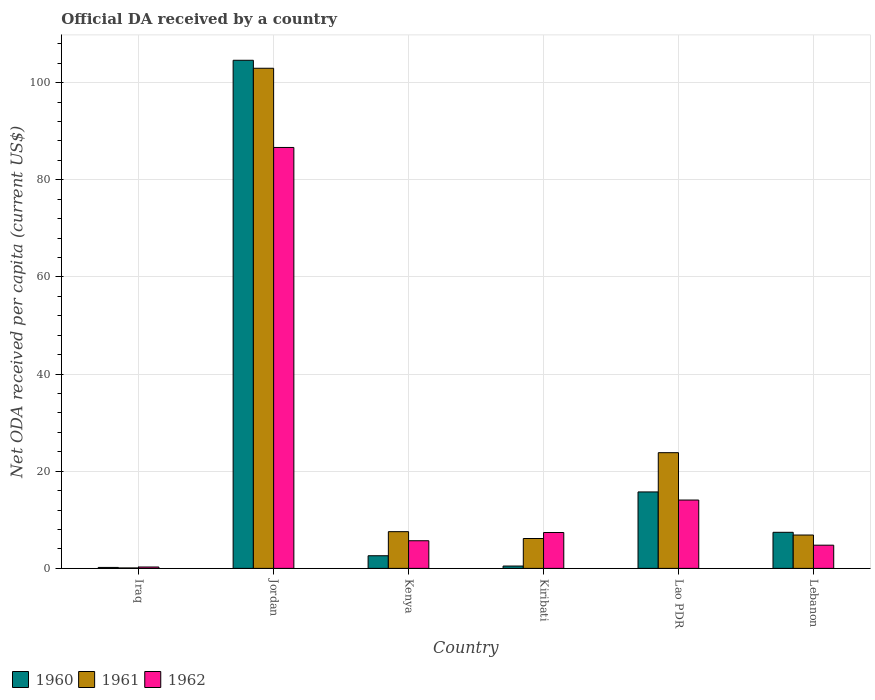How many different coloured bars are there?
Offer a very short reply. 3. Are the number of bars on each tick of the X-axis equal?
Keep it short and to the point. Yes. How many bars are there on the 4th tick from the left?
Offer a terse response. 3. How many bars are there on the 2nd tick from the right?
Offer a terse response. 3. What is the label of the 5th group of bars from the left?
Your answer should be compact. Lao PDR. In how many cases, is the number of bars for a given country not equal to the number of legend labels?
Provide a succinct answer. 0. What is the ODA received in in 1960 in Lebanon?
Your answer should be very brief. 7.43. Across all countries, what is the maximum ODA received in in 1961?
Keep it short and to the point. 102.97. Across all countries, what is the minimum ODA received in in 1960?
Your response must be concise. 0.2. In which country was the ODA received in in 1961 maximum?
Offer a terse response. Jordan. In which country was the ODA received in in 1961 minimum?
Offer a very short reply. Iraq. What is the total ODA received in in 1960 in the graph?
Ensure brevity in your answer.  131.07. What is the difference between the ODA received in in 1960 in Iraq and that in Kiribati?
Your response must be concise. -0.29. What is the difference between the ODA received in in 1961 in Iraq and the ODA received in in 1960 in Jordan?
Make the answer very short. -104.52. What is the average ODA received in in 1960 per country?
Offer a very short reply. 21.84. What is the difference between the ODA received in of/in 1960 and ODA received in of/in 1962 in Lao PDR?
Give a very brief answer. 1.67. In how many countries, is the ODA received in in 1961 greater than 12 US$?
Offer a very short reply. 2. What is the ratio of the ODA received in in 1961 in Kiribati to that in Lebanon?
Offer a terse response. 0.9. Is the ODA received in in 1961 in Iraq less than that in Kenya?
Ensure brevity in your answer.  Yes. Is the difference between the ODA received in in 1960 in Kiribati and Lebanon greater than the difference between the ODA received in in 1962 in Kiribati and Lebanon?
Offer a terse response. No. What is the difference between the highest and the second highest ODA received in in 1961?
Make the answer very short. -95.4. What is the difference between the highest and the lowest ODA received in in 1960?
Ensure brevity in your answer.  104.41. Is the sum of the ODA received in in 1961 in Kenya and Lao PDR greater than the maximum ODA received in in 1960 across all countries?
Ensure brevity in your answer.  No. What does the 1st bar from the left in Iraq represents?
Your response must be concise. 1960. What does the 1st bar from the right in Jordan represents?
Provide a short and direct response. 1962. How many bars are there?
Your answer should be very brief. 18. Are all the bars in the graph horizontal?
Your response must be concise. No. How many countries are there in the graph?
Give a very brief answer. 6. Are the values on the major ticks of Y-axis written in scientific E-notation?
Your response must be concise. No. Where does the legend appear in the graph?
Provide a short and direct response. Bottom left. How many legend labels are there?
Offer a very short reply. 3. How are the legend labels stacked?
Your answer should be compact. Horizontal. What is the title of the graph?
Your answer should be compact. Official DA received by a country. What is the label or title of the X-axis?
Your answer should be compact. Country. What is the label or title of the Y-axis?
Keep it short and to the point. Net ODA received per capita (current US$). What is the Net ODA received per capita (current US$) in 1960 in Iraq?
Keep it short and to the point. 0.2. What is the Net ODA received per capita (current US$) of 1961 in Iraq?
Keep it short and to the point. 0.09. What is the Net ODA received per capita (current US$) in 1962 in Iraq?
Your response must be concise. 0.28. What is the Net ODA received per capita (current US$) of 1960 in Jordan?
Offer a terse response. 104.61. What is the Net ODA received per capita (current US$) in 1961 in Jordan?
Give a very brief answer. 102.97. What is the Net ODA received per capita (current US$) in 1962 in Jordan?
Your answer should be very brief. 86.66. What is the Net ODA received per capita (current US$) of 1960 in Kenya?
Your response must be concise. 2.6. What is the Net ODA received per capita (current US$) of 1961 in Kenya?
Make the answer very short. 7.56. What is the Net ODA received per capita (current US$) of 1962 in Kenya?
Offer a very short reply. 5.69. What is the Net ODA received per capita (current US$) of 1960 in Kiribati?
Make the answer very short. 0.49. What is the Net ODA received per capita (current US$) in 1961 in Kiribati?
Your answer should be very brief. 6.15. What is the Net ODA received per capita (current US$) in 1962 in Kiribati?
Offer a terse response. 7.39. What is the Net ODA received per capita (current US$) in 1960 in Lao PDR?
Offer a terse response. 15.74. What is the Net ODA received per capita (current US$) in 1961 in Lao PDR?
Keep it short and to the point. 23.82. What is the Net ODA received per capita (current US$) in 1962 in Lao PDR?
Offer a terse response. 14.07. What is the Net ODA received per capita (current US$) of 1960 in Lebanon?
Provide a succinct answer. 7.43. What is the Net ODA received per capita (current US$) in 1961 in Lebanon?
Your answer should be very brief. 6.87. What is the Net ODA received per capita (current US$) in 1962 in Lebanon?
Make the answer very short. 4.78. Across all countries, what is the maximum Net ODA received per capita (current US$) of 1960?
Provide a short and direct response. 104.61. Across all countries, what is the maximum Net ODA received per capita (current US$) in 1961?
Provide a succinct answer. 102.97. Across all countries, what is the maximum Net ODA received per capita (current US$) in 1962?
Make the answer very short. 86.66. Across all countries, what is the minimum Net ODA received per capita (current US$) in 1960?
Make the answer very short. 0.2. Across all countries, what is the minimum Net ODA received per capita (current US$) in 1961?
Ensure brevity in your answer.  0.09. Across all countries, what is the minimum Net ODA received per capita (current US$) in 1962?
Make the answer very short. 0.28. What is the total Net ODA received per capita (current US$) in 1960 in the graph?
Offer a very short reply. 131.07. What is the total Net ODA received per capita (current US$) in 1961 in the graph?
Keep it short and to the point. 147.47. What is the total Net ODA received per capita (current US$) in 1962 in the graph?
Provide a short and direct response. 118.88. What is the difference between the Net ODA received per capita (current US$) of 1960 in Iraq and that in Jordan?
Your answer should be very brief. -104.41. What is the difference between the Net ODA received per capita (current US$) in 1961 in Iraq and that in Jordan?
Offer a very short reply. -102.88. What is the difference between the Net ODA received per capita (current US$) of 1962 in Iraq and that in Jordan?
Your answer should be compact. -86.38. What is the difference between the Net ODA received per capita (current US$) of 1960 in Iraq and that in Kenya?
Your answer should be compact. -2.41. What is the difference between the Net ODA received per capita (current US$) in 1961 in Iraq and that in Kenya?
Ensure brevity in your answer.  -7.47. What is the difference between the Net ODA received per capita (current US$) of 1962 in Iraq and that in Kenya?
Provide a short and direct response. -5.41. What is the difference between the Net ODA received per capita (current US$) of 1960 in Iraq and that in Kiribati?
Give a very brief answer. -0.29. What is the difference between the Net ODA received per capita (current US$) in 1961 in Iraq and that in Kiribati?
Your answer should be compact. -6.06. What is the difference between the Net ODA received per capita (current US$) of 1962 in Iraq and that in Kiribati?
Ensure brevity in your answer.  -7.1. What is the difference between the Net ODA received per capita (current US$) in 1960 in Iraq and that in Lao PDR?
Offer a very short reply. -15.54. What is the difference between the Net ODA received per capita (current US$) of 1961 in Iraq and that in Lao PDR?
Keep it short and to the point. -23.73. What is the difference between the Net ODA received per capita (current US$) in 1962 in Iraq and that in Lao PDR?
Provide a short and direct response. -13.79. What is the difference between the Net ODA received per capita (current US$) of 1960 in Iraq and that in Lebanon?
Provide a short and direct response. -7.23. What is the difference between the Net ODA received per capita (current US$) of 1961 in Iraq and that in Lebanon?
Make the answer very short. -6.78. What is the difference between the Net ODA received per capita (current US$) in 1962 in Iraq and that in Lebanon?
Your answer should be compact. -4.49. What is the difference between the Net ODA received per capita (current US$) of 1960 in Jordan and that in Kenya?
Keep it short and to the point. 102. What is the difference between the Net ODA received per capita (current US$) in 1961 in Jordan and that in Kenya?
Your response must be concise. 95.4. What is the difference between the Net ODA received per capita (current US$) in 1962 in Jordan and that in Kenya?
Give a very brief answer. 80.97. What is the difference between the Net ODA received per capita (current US$) in 1960 in Jordan and that in Kiribati?
Make the answer very short. 104.12. What is the difference between the Net ODA received per capita (current US$) of 1961 in Jordan and that in Kiribati?
Give a very brief answer. 96.81. What is the difference between the Net ODA received per capita (current US$) of 1962 in Jordan and that in Kiribati?
Your answer should be compact. 79.27. What is the difference between the Net ODA received per capita (current US$) of 1960 in Jordan and that in Lao PDR?
Your answer should be compact. 88.87. What is the difference between the Net ODA received per capita (current US$) in 1961 in Jordan and that in Lao PDR?
Your answer should be very brief. 79.14. What is the difference between the Net ODA received per capita (current US$) of 1962 in Jordan and that in Lao PDR?
Offer a very short reply. 72.59. What is the difference between the Net ODA received per capita (current US$) in 1960 in Jordan and that in Lebanon?
Your response must be concise. 97.18. What is the difference between the Net ODA received per capita (current US$) of 1961 in Jordan and that in Lebanon?
Provide a short and direct response. 96.1. What is the difference between the Net ODA received per capita (current US$) of 1962 in Jordan and that in Lebanon?
Make the answer very short. 81.88. What is the difference between the Net ODA received per capita (current US$) of 1960 in Kenya and that in Kiribati?
Provide a short and direct response. 2.12. What is the difference between the Net ODA received per capita (current US$) of 1961 in Kenya and that in Kiribati?
Give a very brief answer. 1.41. What is the difference between the Net ODA received per capita (current US$) of 1962 in Kenya and that in Kiribati?
Provide a succinct answer. -1.7. What is the difference between the Net ODA received per capita (current US$) in 1960 in Kenya and that in Lao PDR?
Keep it short and to the point. -13.14. What is the difference between the Net ODA received per capita (current US$) of 1961 in Kenya and that in Lao PDR?
Provide a succinct answer. -16.26. What is the difference between the Net ODA received per capita (current US$) in 1962 in Kenya and that in Lao PDR?
Offer a terse response. -8.38. What is the difference between the Net ODA received per capita (current US$) in 1960 in Kenya and that in Lebanon?
Your answer should be compact. -4.83. What is the difference between the Net ODA received per capita (current US$) of 1961 in Kenya and that in Lebanon?
Offer a terse response. 0.69. What is the difference between the Net ODA received per capita (current US$) of 1962 in Kenya and that in Lebanon?
Give a very brief answer. 0.91. What is the difference between the Net ODA received per capita (current US$) in 1960 in Kiribati and that in Lao PDR?
Offer a very short reply. -15.26. What is the difference between the Net ODA received per capita (current US$) in 1961 in Kiribati and that in Lao PDR?
Give a very brief answer. -17.67. What is the difference between the Net ODA received per capita (current US$) in 1962 in Kiribati and that in Lao PDR?
Keep it short and to the point. -6.68. What is the difference between the Net ODA received per capita (current US$) of 1960 in Kiribati and that in Lebanon?
Provide a short and direct response. -6.94. What is the difference between the Net ODA received per capita (current US$) of 1961 in Kiribati and that in Lebanon?
Provide a succinct answer. -0.72. What is the difference between the Net ODA received per capita (current US$) of 1962 in Kiribati and that in Lebanon?
Make the answer very short. 2.61. What is the difference between the Net ODA received per capita (current US$) of 1960 in Lao PDR and that in Lebanon?
Keep it short and to the point. 8.31. What is the difference between the Net ODA received per capita (current US$) of 1961 in Lao PDR and that in Lebanon?
Give a very brief answer. 16.95. What is the difference between the Net ODA received per capita (current US$) in 1962 in Lao PDR and that in Lebanon?
Give a very brief answer. 9.29. What is the difference between the Net ODA received per capita (current US$) of 1960 in Iraq and the Net ODA received per capita (current US$) of 1961 in Jordan?
Ensure brevity in your answer.  -102.77. What is the difference between the Net ODA received per capita (current US$) in 1960 in Iraq and the Net ODA received per capita (current US$) in 1962 in Jordan?
Provide a short and direct response. -86.46. What is the difference between the Net ODA received per capita (current US$) in 1961 in Iraq and the Net ODA received per capita (current US$) in 1962 in Jordan?
Offer a terse response. -86.57. What is the difference between the Net ODA received per capita (current US$) in 1960 in Iraq and the Net ODA received per capita (current US$) in 1961 in Kenya?
Provide a short and direct response. -7.36. What is the difference between the Net ODA received per capita (current US$) of 1960 in Iraq and the Net ODA received per capita (current US$) of 1962 in Kenya?
Provide a short and direct response. -5.49. What is the difference between the Net ODA received per capita (current US$) in 1961 in Iraq and the Net ODA received per capita (current US$) in 1962 in Kenya?
Provide a short and direct response. -5.6. What is the difference between the Net ODA received per capita (current US$) of 1960 in Iraq and the Net ODA received per capita (current US$) of 1961 in Kiribati?
Keep it short and to the point. -5.95. What is the difference between the Net ODA received per capita (current US$) in 1960 in Iraq and the Net ODA received per capita (current US$) in 1962 in Kiribati?
Offer a terse response. -7.19. What is the difference between the Net ODA received per capita (current US$) of 1961 in Iraq and the Net ODA received per capita (current US$) of 1962 in Kiribati?
Give a very brief answer. -7.3. What is the difference between the Net ODA received per capita (current US$) of 1960 in Iraq and the Net ODA received per capita (current US$) of 1961 in Lao PDR?
Give a very brief answer. -23.62. What is the difference between the Net ODA received per capita (current US$) of 1960 in Iraq and the Net ODA received per capita (current US$) of 1962 in Lao PDR?
Your response must be concise. -13.87. What is the difference between the Net ODA received per capita (current US$) in 1961 in Iraq and the Net ODA received per capita (current US$) in 1962 in Lao PDR?
Provide a short and direct response. -13.98. What is the difference between the Net ODA received per capita (current US$) in 1960 in Iraq and the Net ODA received per capita (current US$) in 1961 in Lebanon?
Offer a very short reply. -6.67. What is the difference between the Net ODA received per capita (current US$) in 1960 in Iraq and the Net ODA received per capita (current US$) in 1962 in Lebanon?
Your answer should be very brief. -4.58. What is the difference between the Net ODA received per capita (current US$) of 1961 in Iraq and the Net ODA received per capita (current US$) of 1962 in Lebanon?
Offer a very short reply. -4.69. What is the difference between the Net ODA received per capita (current US$) of 1960 in Jordan and the Net ODA received per capita (current US$) of 1961 in Kenya?
Make the answer very short. 97.05. What is the difference between the Net ODA received per capita (current US$) of 1960 in Jordan and the Net ODA received per capita (current US$) of 1962 in Kenya?
Ensure brevity in your answer.  98.92. What is the difference between the Net ODA received per capita (current US$) in 1961 in Jordan and the Net ODA received per capita (current US$) in 1962 in Kenya?
Make the answer very short. 97.27. What is the difference between the Net ODA received per capita (current US$) of 1960 in Jordan and the Net ODA received per capita (current US$) of 1961 in Kiribati?
Your answer should be compact. 98.46. What is the difference between the Net ODA received per capita (current US$) in 1960 in Jordan and the Net ODA received per capita (current US$) in 1962 in Kiribati?
Your answer should be very brief. 97.22. What is the difference between the Net ODA received per capita (current US$) in 1961 in Jordan and the Net ODA received per capita (current US$) in 1962 in Kiribati?
Offer a terse response. 95.58. What is the difference between the Net ODA received per capita (current US$) of 1960 in Jordan and the Net ODA received per capita (current US$) of 1961 in Lao PDR?
Give a very brief answer. 80.79. What is the difference between the Net ODA received per capita (current US$) of 1960 in Jordan and the Net ODA received per capita (current US$) of 1962 in Lao PDR?
Your answer should be compact. 90.54. What is the difference between the Net ODA received per capita (current US$) in 1961 in Jordan and the Net ODA received per capita (current US$) in 1962 in Lao PDR?
Make the answer very short. 88.89. What is the difference between the Net ODA received per capita (current US$) of 1960 in Jordan and the Net ODA received per capita (current US$) of 1961 in Lebanon?
Provide a short and direct response. 97.74. What is the difference between the Net ODA received per capita (current US$) in 1960 in Jordan and the Net ODA received per capita (current US$) in 1962 in Lebanon?
Your answer should be very brief. 99.83. What is the difference between the Net ODA received per capita (current US$) of 1961 in Jordan and the Net ODA received per capita (current US$) of 1962 in Lebanon?
Offer a terse response. 98.19. What is the difference between the Net ODA received per capita (current US$) of 1960 in Kenya and the Net ODA received per capita (current US$) of 1961 in Kiribati?
Ensure brevity in your answer.  -3.55. What is the difference between the Net ODA received per capita (current US$) of 1960 in Kenya and the Net ODA received per capita (current US$) of 1962 in Kiribati?
Keep it short and to the point. -4.78. What is the difference between the Net ODA received per capita (current US$) of 1961 in Kenya and the Net ODA received per capita (current US$) of 1962 in Kiribati?
Offer a terse response. 0.17. What is the difference between the Net ODA received per capita (current US$) in 1960 in Kenya and the Net ODA received per capita (current US$) in 1961 in Lao PDR?
Provide a short and direct response. -21.22. What is the difference between the Net ODA received per capita (current US$) of 1960 in Kenya and the Net ODA received per capita (current US$) of 1962 in Lao PDR?
Provide a short and direct response. -11.47. What is the difference between the Net ODA received per capita (current US$) in 1961 in Kenya and the Net ODA received per capita (current US$) in 1962 in Lao PDR?
Make the answer very short. -6.51. What is the difference between the Net ODA received per capita (current US$) of 1960 in Kenya and the Net ODA received per capita (current US$) of 1961 in Lebanon?
Your answer should be very brief. -4.27. What is the difference between the Net ODA received per capita (current US$) in 1960 in Kenya and the Net ODA received per capita (current US$) in 1962 in Lebanon?
Your answer should be very brief. -2.17. What is the difference between the Net ODA received per capita (current US$) in 1961 in Kenya and the Net ODA received per capita (current US$) in 1962 in Lebanon?
Offer a very short reply. 2.78. What is the difference between the Net ODA received per capita (current US$) of 1960 in Kiribati and the Net ODA received per capita (current US$) of 1961 in Lao PDR?
Ensure brevity in your answer.  -23.34. What is the difference between the Net ODA received per capita (current US$) in 1960 in Kiribati and the Net ODA received per capita (current US$) in 1962 in Lao PDR?
Make the answer very short. -13.59. What is the difference between the Net ODA received per capita (current US$) in 1961 in Kiribati and the Net ODA received per capita (current US$) in 1962 in Lao PDR?
Give a very brief answer. -7.92. What is the difference between the Net ODA received per capita (current US$) of 1960 in Kiribati and the Net ODA received per capita (current US$) of 1961 in Lebanon?
Give a very brief answer. -6.39. What is the difference between the Net ODA received per capita (current US$) of 1960 in Kiribati and the Net ODA received per capita (current US$) of 1962 in Lebanon?
Provide a succinct answer. -4.29. What is the difference between the Net ODA received per capita (current US$) in 1961 in Kiribati and the Net ODA received per capita (current US$) in 1962 in Lebanon?
Your answer should be very brief. 1.37. What is the difference between the Net ODA received per capita (current US$) of 1960 in Lao PDR and the Net ODA received per capita (current US$) of 1961 in Lebanon?
Offer a very short reply. 8.87. What is the difference between the Net ODA received per capita (current US$) in 1960 in Lao PDR and the Net ODA received per capita (current US$) in 1962 in Lebanon?
Your response must be concise. 10.96. What is the difference between the Net ODA received per capita (current US$) of 1961 in Lao PDR and the Net ODA received per capita (current US$) of 1962 in Lebanon?
Your answer should be very brief. 19.05. What is the average Net ODA received per capita (current US$) of 1960 per country?
Offer a terse response. 21.84. What is the average Net ODA received per capita (current US$) in 1961 per country?
Make the answer very short. 24.58. What is the average Net ODA received per capita (current US$) of 1962 per country?
Your answer should be compact. 19.81. What is the difference between the Net ODA received per capita (current US$) of 1960 and Net ODA received per capita (current US$) of 1961 in Iraq?
Provide a short and direct response. 0.11. What is the difference between the Net ODA received per capita (current US$) of 1960 and Net ODA received per capita (current US$) of 1962 in Iraq?
Make the answer very short. -0.09. What is the difference between the Net ODA received per capita (current US$) in 1961 and Net ODA received per capita (current US$) in 1962 in Iraq?
Your response must be concise. -0.19. What is the difference between the Net ODA received per capita (current US$) of 1960 and Net ODA received per capita (current US$) of 1961 in Jordan?
Provide a succinct answer. 1.64. What is the difference between the Net ODA received per capita (current US$) in 1960 and Net ODA received per capita (current US$) in 1962 in Jordan?
Make the answer very short. 17.95. What is the difference between the Net ODA received per capita (current US$) in 1961 and Net ODA received per capita (current US$) in 1962 in Jordan?
Keep it short and to the point. 16.3. What is the difference between the Net ODA received per capita (current US$) of 1960 and Net ODA received per capita (current US$) of 1961 in Kenya?
Offer a terse response. -4.96. What is the difference between the Net ODA received per capita (current US$) in 1960 and Net ODA received per capita (current US$) in 1962 in Kenya?
Keep it short and to the point. -3.09. What is the difference between the Net ODA received per capita (current US$) of 1961 and Net ODA received per capita (current US$) of 1962 in Kenya?
Provide a short and direct response. 1.87. What is the difference between the Net ODA received per capita (current US$) in 1960 and Net ODA received per capita (current US$) in 1961 in Kiribati?
Provide a succinct answer. -5.67. What is the difference between the Net ODA received per capita (current US$) in 1960 and Net ODA received per capita (current US$) in 1962 in Kiribati?
Keep it short and to the point. -6.9. What is the difference between the Net ODA received per capita (current US$) of 1961 and Net ODA received per capita (current US$) of 1962 in Kiribati?
Your response must be concise. -1.24. What is the difference between the Net ODA received per capita (current US$) of 1960 and Net ODA received per capita (current US$) of 1961 in Lao PDR?
Your answer should be compact. -8.08. What is the difference between the Net ODA received per capita (current US$) in 1960 and Net ODA received per capita (current US$) in 1962 in Lao PDR?
Your answer should be very brief. 1.67. What is the difference between the Net ODA received per capita (current US$) of 1961 and Net ODA received per capita (current US$) of 1962 in Lao PDR?
Give a very brief answer. 9.75. What is the difference between the Net ODA received per capita (current US$) in 1960 and Net ODA received per capita (current US$) in 1961 in Lebanon?
Provide a short and direct response. 0.56. What is the difference between the Net ODA received per capita (current US$) of 1960 and Net ODA received per capita (current US$) of 1962 in Lebanon?
Keep it short and to the point. 2.65. What is the difference between the Net ODA received per capita (current US$) in 1961 and Net ODA received per capita (current US$) in 1962 in Lebanon?
Keep it short and to the point. 2.09. What is the ratio of the Net ODA received per capita (current US$) in 1960 in Iraq to that in Jordan?
Your answer should be compact. 0. What is the ratio of the Net ODA received per capita (current US$) in 1961 in Iraq to that in Jordan?
Give a very brief answer. 0. What is the ratio of the Net ODA received per capita (current US$) in 1962 in Iraq to that in Jordan?
Give a very brief answer. 0. What is the ratio of the Net ODA received per capita (current US$) of 1960 in Iraq to that in Kenya?
Your answer should be compact. 0.08. What is the ratio of the Net ODA received per capita (current US$) of 1961 in Iraq to that in Kenya?
Your response must be concise. 0.01. What is the ratio of the Net ODA received per capita (current US$) of 1962 in Iraq to that in Kenya?
Offer a very short reply. 0.05. What is the ratio of the Net ODA received per capita (current US$) in 1960 in Iraq to that in Kiribati?
Keep it short and to the point. 0.41. What is the ratio of the Net ODA received per capita (current US$) of 1961 in Iraq to that in Kiribati?
Give a very brief answer. 0.01. What is the ratio of the Net ODA received per capita (current US$) in 1962 in Iraq to that in Kiribati?
Make the answer very short. 0.04. What is the ratio of the Net ODA received per capita (current US$) in 1960 in Iraq to that in Lao PDR?
Give a very brief answer. 0.01. What is the ratio of the Net ODA received per capita (current US$) in 1961 in Iraq to that in Lao PDR?
Offer a very short reply. 0. What is the ratio of the Net ODA received per capita (current US$) in 1962 in Iraq to that in Lao PDR?
Offer a very short reply. 0.02. What is the ratio of the Net ODA received per capita (current US$) of 1960 in Iraq to that in Lebanon?
Offer a terse response. 0.03. What is the ratio of the Net ODA received per capita (current US$) of 1961 in Iraq to that in Lebanon?
Your answer should be compact. 0.01. What is the ratio of the Net ODA received per capita (current US$) in 1962 in Iraq to that in Lebanon?
Offer a terse response. 0.06. What is the ratio of the Net ODA received per capita (current US$) in 1960 in Jordan to that in Kenya?
Give a very brief answer. 40.17. What is the ratio of the Net ODA received per capita (current US$) of 1961 in Jordan to that in Kenya?
Ensure brevity in your answer.  13.62. What is the ratio of the Net ODA received per capita (current US$) in 1962 in Jordan to that in Kenya?
Your response must be concise. 15.22. What is the ratio of the Net ODA received per capita (current US$) of 1960 in Jordan to that in Kiribati?
Your answer should be very brief. 215.67. What is the ratio of the Net ODA received per capita (current US$) in 1961 in Jordan to that in Kiribati?
Give a very brief answer. 16.74. What is the ratio of the Net ODA received per capita (current US$) of 1962 in Jordan to that in Kiribati?
Keep it short and to the point. 11.73. What is the ratio of the Net ODA received per capita (current US$) of 1960 in Jordan to that in Lao PDR?
Your response must be concise. 6.65. What is the ratio of the Net ODA received per capita (current US$) of 1961 in Jordan to that in Lao PDR?
Give a very brief answer. 4.32. What is the ratio of the Net ODA received per capita (current US$) of 1962 in Jordan to that in Lao PDR?
Provide a short and direct response. 6.16. What is the ratio of the Net ODA received per capita (current US$) in 1960 in Jordan to that in Lebanon?
Your response must be concise. 14.08. What is the ratio of the Net ODA received per capita (current US$) in 1961 in Jordan to that in Lebanon?
Offer a very short reply. 14.99. What is the ratio of the Net ODA received per capita (current US$) of 1962 in Jordan to that in Lebanon?
Give a very brief answer. 18.14. What is the ratio of the Net ODA received per capita (current US$) in 1960 in Kenya to that in Kiribati?
Provide a succinct answer. 5.37. What is the ratio of the Net ODA received per capita (current US$) of 1961 in Kenya to that in Kiribati?
Your response must be concise. 1.23. What is the ratio of the Net ODA received per capita (current US$) of 1962 in Kenya to that in Kiribati?
Make the answer very short. 0.77. What is the ratio of the Net ODA received per capita (current US$) of 1960 in Kenya to that in Lao PDR?
Offer a very short reply. 0.17. What is the ratio of the Net ODA received per capita (current US$) in 1961 in Kenya to that in Lao PDR?
Your response must be concise. 0.32. What is the ratio of the Net ODA received per capita (current US$) in 1962 in Kenya to that in Lao PDR?
Provide a succinct answer. 0.4. What is the ratio of the Net ODA received per capita (current US$) of 1960 in Kenya to that in Lebanon?
Provide a short and direct response. 0.35. What is the ratio of the Net ODA received per capita (current US$) of 1961 in Kenya to that in Lebanon?
Ensure brevity in your answer.  1.1. What is the ratio of the Net ODA received per capita (current US$) in 1962 in Kenya to that in Lebanon?
Keep it short and to the point. 1.19. What is the ratio of the Net ODA received per capita (current US$) of 1960 in Kiribati to that in Lao PDR?
Ensure brevity in your answer.  0.03. What is the ratio of the Net ODA received per capita (current US$) of 1961 in Kiribati to that in Lao PDR?
Your response must be concise. 0.26. What is the ratio of the Net ODA received per capita (current US$) in 1962 in Kiribati to that in Lao PDR?
Ensure brevity in your answer.  0.53. What is the ratio of the Net ODA received per capita (current US$) in 1960 in Kiribati to that in Lebanon?
Keep it short and to the point. 0.07. What is the ratio of the Net ODA received per capita (current US$) in 1961 in Kiribati to that in Lebanon?
Offer a very short reply. 0.9. What is the ratio of the Net ODA received per capita (current US$) in 1962 in Kiribati to that in Lebanon?
Offer a very short reply. 1.55. What is the ratio of the Net ODA received per capita (current US$) of 1960 in Lao PDR to that in Lebanon?
Your response must be concise. 2.12. What is the ratio of the Net ODA received per capita (current US$) in 1961 in Lao PDR to that in Lebanon?
Provide a short and direct response. 3.47. What is the ratio of the Net ODA received per capita (current US$) in 1962 in Lao PDR to that in Lebanon?
Your answer should be compact. 2.94. What is the difference between the highest and the second highest Net ODA received per capita (current US$) in 1960?
Your answer should be very brief. 88.87. What is the difference between the highest and the second highest Net ODA received per capita (current US$) of 1961?
Your answer should be compact. 79.14. What is the difference between the highest and the second highest Net ODA received per capita (current US$) of 1962?
Offer a very short reply. 72.59. What is the difference between the highest and the lowest Net ODA received per capita (current US$) in 1960?
Your answer should be compact. 104.41. What is the difference between the highest and the lowest Net ODA received per capita (current US$) in 1961?
Provide a succinct answer. 102.88. What is the difference between the highest and the lowest Net ODA received per capita (current US$) in 1962?
Make the answer very short. 86.38. 